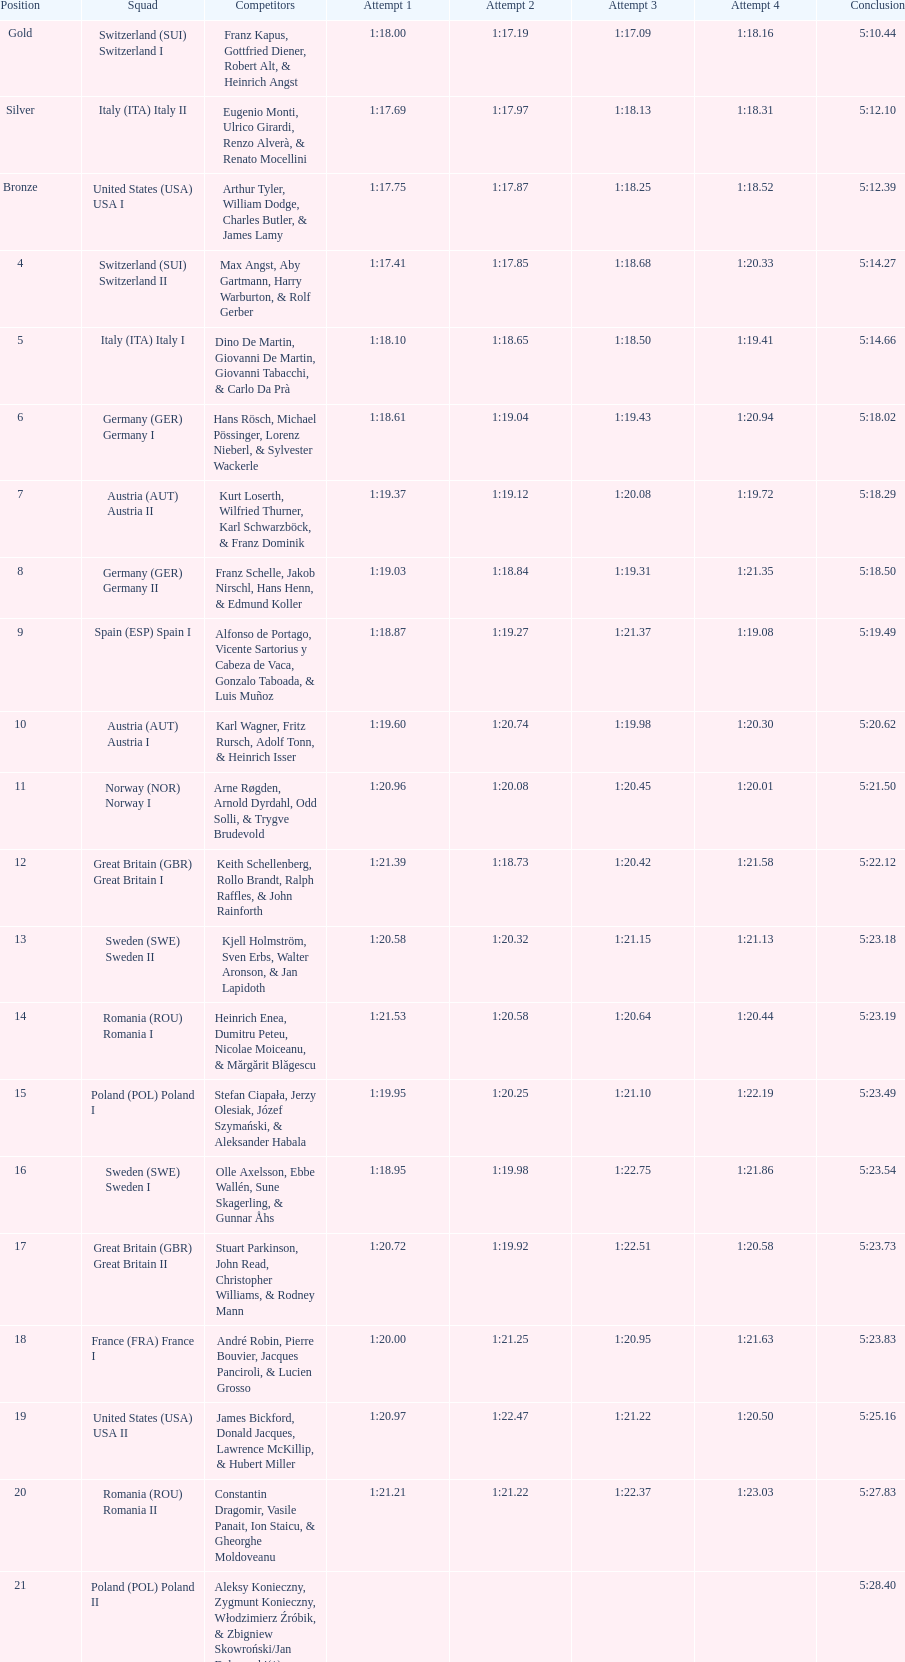Which team had the most time? Poland. 